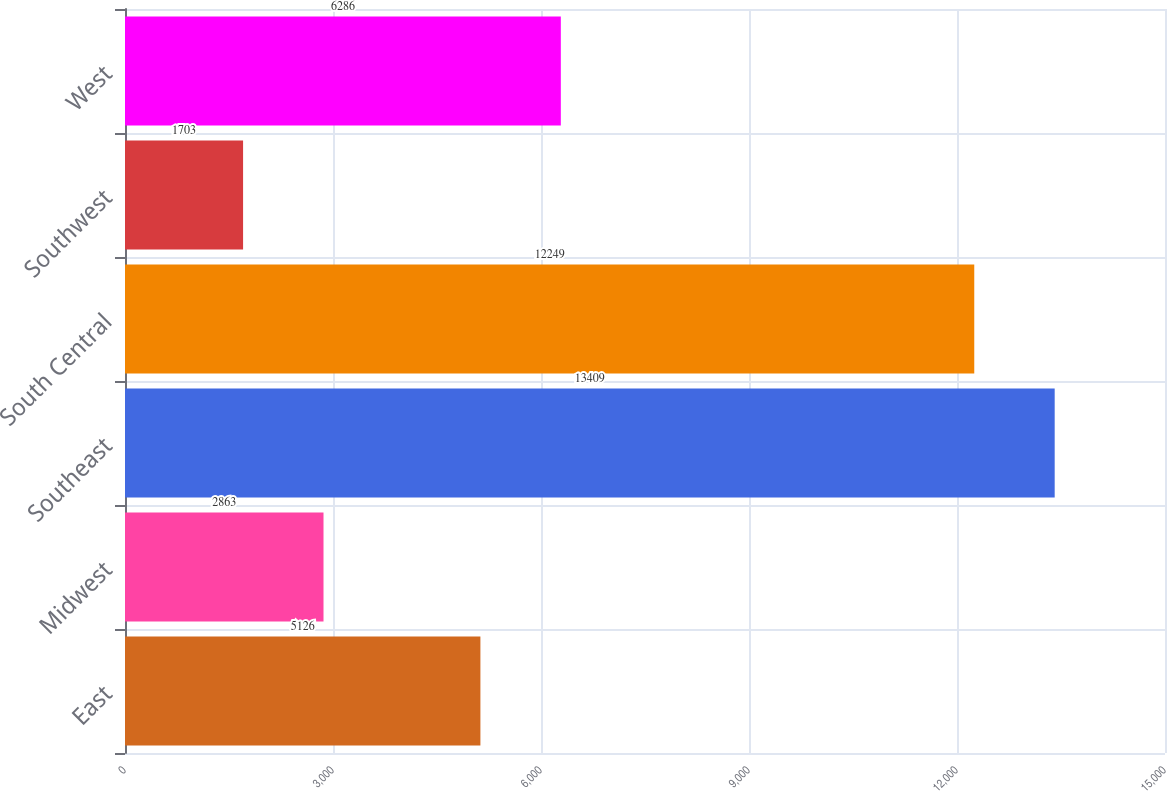Convert chart. <chart><loc_0><loc_0><loc_500><loc_500><bar_chart><fcel>East<fcel>Midwest<fcel>Southeast<fcel>South Central<fcel>Southwest<fcel>West<nl><fcel>5126<fcel>2863<fcel>13409<fcel>12249<fcel>1703<fcel>6286<nl></chart> 